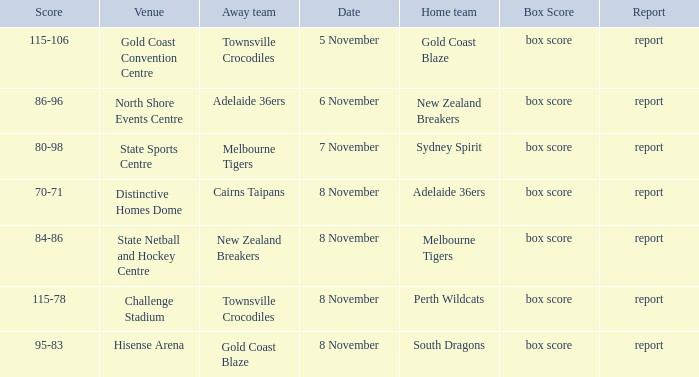What was the date that featured a game against Gold Coast Blaze? 8 November. Could you help me parse every detail presented in this table? {'header': ['Score', 'Venue', 'Away team', 'Date', 'Home team', 'Box Score', 'Report'], 'rows': [['115-106', 'Gold Coast Convention Centre', 'Townsville Crocodiles', '5 November', 'Gold Coast Blaze', 'box score', 'report'], ['86-96', 'North Shore Events Centre', 'Adelaide 36ers', '6 November', 'New Zealand Breakers', 'box score', 'report'], ['80-98', 'State Sports Centre', 'Melbourne Tigers', '7 November', 'Sydney Spirit', 'box score', 'report'], ['70-71', 'Distinctive Homes Dome', 'Cairns Taipans', '8 November', 'Adelaide 36ers', 'box score', 'report'], ['84-86', 'State Netball and Hockey Centre', 'New Zealand Breakers', '8 November', 'Melbourne Tigers', 'box score', 'report'], ['115-78', 'Challenge Stadium', 'Townsville Crocodiles', '8 November', 'Perth Wildcats', 'box score', 'report'], ['95-83', 'Hisense Arena', 'Gold Coast Blaze', '8 November', 'South Dragons', 'box score', 'report']]} 